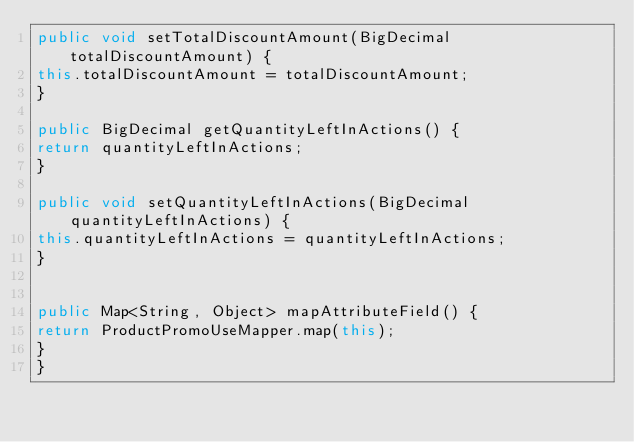Convert code to text. <code><loc_0><loc_0><loc_500><loc_500><_Java_>public void setTotalDiscountAmount(BigDecimal  totalDiscountAmount) {
this.totalDiscountAmount = totalDiscountAmount;
}

public BigDecimal getQuantityLeftInActions() {
return quantityLeftInActions;
}

public void setQuantityLeftInActions(BigDecimal  quantityLeftInActions) {
this.quantityLeftInActions = quantityLeftInActions;
}


public Map<String, Object> mapAttributeField() {
return ProductPromoUseMapper.map(this);
}
}
</code> 